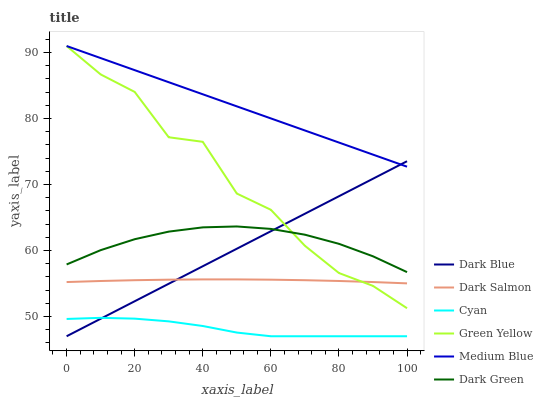Does Cyan have the minimum area under the curve?
Answer yes or no. Yes. Does Medium Blue have the maximum area under the curve?
Answer yes or no. Yes. Does Dark Salmon have the minimum area under the curve?
Answer yes or no. No. Does Dark Salmon have the maximum area under the curve?
Answer yes or no. No. Is Medium Blue the smoothest?
Answer yes or no. Yes. Is Green Yellow the roughest?
Answer yes or no. Yes. Is Dark Salmon the smoothest?
Answer yes or no. No. Is Dark Salmon the roughest?
Answer yes or no. No. Does Dark Blue have the lowest value?
Answer yes or no. Yes. Does Dark Salmon have the lowest value?
Answer yes or no. No. Does Green Yellow have the highest value?
Answer yes or no. Yes. Does Dark Salmon have the highest value?
Answer yes or no. No. Is Dark Salmon less than Dark Green?
Answer yes or no. Yes. Is Medium Blue greater than Dark Green?
Answer yes or no. Yes. Does Green Yellow intersect Dark Salmon?
Answer yes or no. Yes. Is Green Yellow less than Dark Salmon?
Answer yes or no. No. Is Green Yellow greater than Dark Salmon?
Answer yes or no. No. Does Dark Salmon intersect Dark Green?
Answer yes or no. No. 